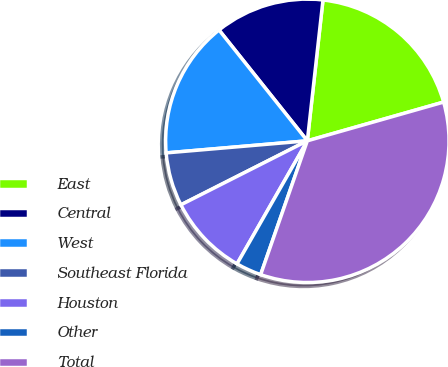Convert chart. <chart><loc_0><loc_0><loc_500><loc_500><pie_chart><fcel>East<fcel>Central<fcel>West<fcel>Southeast Florida<fcel>Houston<fcel>Other<fcel>Total<nl><fcel>18.83%<fcel>12.47%<fcel>15.65%<fcel>6.1%<fcel>9.28%<fcel>2.92%<fcel>34.75%<nl></chart> 